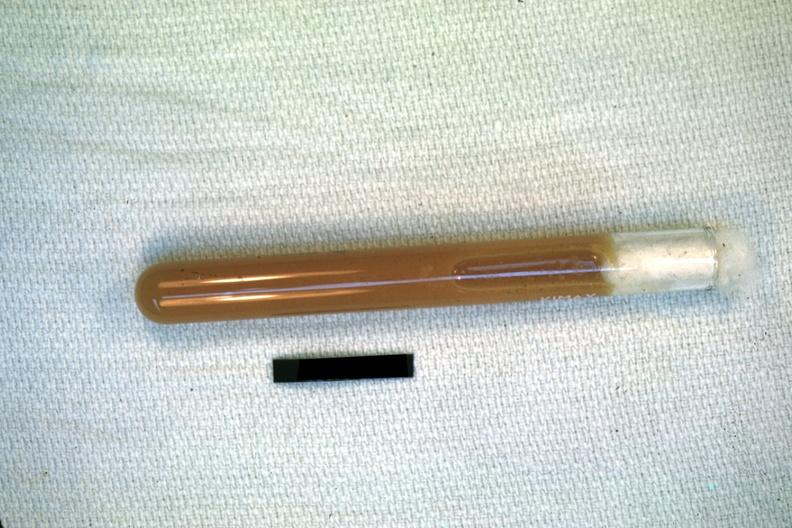does this image show case of peritonitis slide illustrates pus from the peritoneal cavity?
Answer the question using a single word or phrase. Yes 